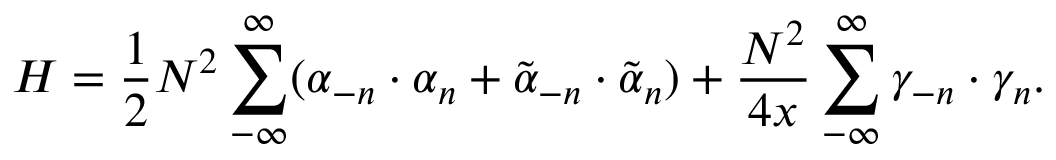Convert formula to latex. <formula><loc_0><loc_0><loc_500><loc_500>H = \frac { 1 } { 2 } N ^ { 2 } \sum _ { - \infty } ^ { \infty } ( \alpha _ { - n } \cdot \alpha _ { n } + \tilde { \alpha } _ { - n } \cdot \tilde { \alpha } _ { n } ) + \frac { N ^ { 2 } } { 4 x } \sum _ { - \infty } ^ { \infty } \gamma _ { - n } \cdot \gamma _ { n } .</formula> 